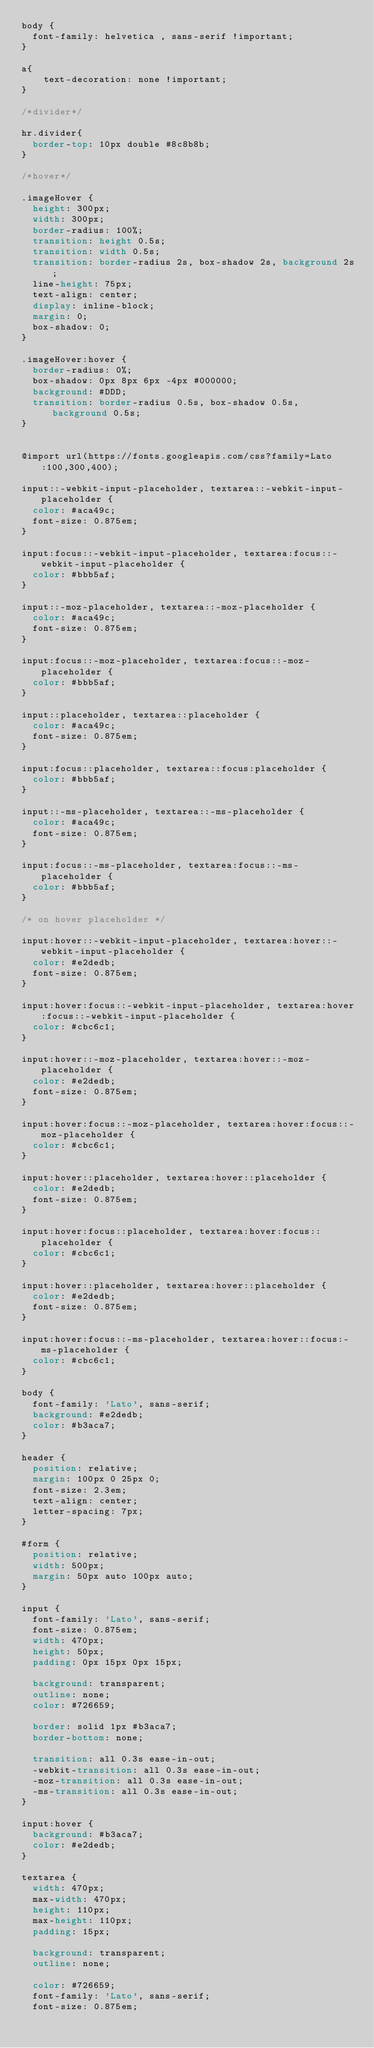Convert code to text. <code><loc_0><loc_0><loc_500><loc_500><_CSS_>body {
  font-family: helvetica , sans-serif !important;
}

a{
    text-decoration: none !important;
}

/*divider*/

hr.divider{
	border-top: 10px double #8c8b8b;
}

/*hover*/

.imageHover {
  height: 300px;
  width: 300px;
  border-radius: 100%;
  transition: height 0.5s;
  transition: width 0.5s;
  transition: border-radius 2s, box-shadow 2s, background 2s;
  line-height: 75px;
  text-align: center;
  display: inline-block;
  margin: 0;
  box-shadow: 0;
}

.imageHover:hover {
  border-radius: 0%;
  box-shadow: 0px 8px 6px -4px #000000;
  background: #DDD;
  transition: border-radius 0.5s, box-shadow 0.5s, background 0.5s;
}


@import url(https://fonts.googleapis.com/css?family=Lato:100,300,400);

input::-webkit-input-placeholder, textarea::-webkit-input-placeholder {
  color: #aca49c;
  font-size: 0.875em;
}

input:focus::-webkit-input-placeholder, textarea:focus::-webkit-input-placeholder {
  color: #bbb5af;
}

input::-moz-placeholder, textarea::-moz-placeholder {
  color: #aca49c;
  font-size: 0.875em;
}

input:focus::-moz-placeholder, textarea:focus::-moz-placeholder {
  color: #bbb5af;
}

input::placeholder, textarea::placeholder {
  color: #aca49c;
  font-size: 0.875em;
}

input:focus::placeholder, textarea::focus:placeholder {
  color: #bbb5af;
}

input::-ms-placeholder, textarea::-ms-placeholder {
  color: #aca49c;
  font-size: 0.875em;
}

input:focus::-ms-placeholder, textarea:focus::-ms-placeholder {
  color: #bbb5af;
}

/* on hover placeholder */

input:hover::-webkit-input-placeholder, textarea:hover::-webkit-input-placeholder {
  color: #e2dedb;
  font-size: 0.875em;
}

input:hover:focus::-webkit-input-placeholder, textarea:hover:focus::-webkit-input-placeholder {
  color: #cbc6c1;
}

input:hover::-moz-placeholder, textarea:hover::-moz-placeholder {
  color: #e2dedb;
  font-size: 0.875em;
}

input:hover:focus::-moz-placeholder, textarea:hover:focus::-moz-placeholder {
  color: #cbc6c1;
}

input:hover::placeholder, textarea:hover::placeholder {
  color: #e2dedb;
  font-size: 0.875em;
}

input:hover:focus::placeholder, textarea:hover:focus::placeholder {
  color: #cbc6c1;
}

input:hover::placeholder, textarea:hover::placeholder {
  color: #e2dedb;
  font-size: 0.875em;
}

input:hover:focus::-ms-placeholder, textarea:hover::focus:-ms-placeholder {
  color: #cbc6c1;
}

body {
  font-family: 'Lato', sans-serif;
  background: #e2dedb;
  color: #b3aca7;
}

header {
  position: relative;
  margin: 100px 0 25px 0;
  font-size: 2.3em;
  text-align: center;
  letter-spacing: 7px;
}

#form {
  position: relative;
  width: 500px;
  margin: 50px auto 100px auto;
}

input {
  font-family: 'Lato', sans-serif;
  font-size: 0.875em;
  width: 470px;
  height: 50px;
  padding: 0px 15px 0px 15px;
  
  background: transparent;
  outline: none;
  color: #726659;
  
  border: solid 1px #b3aca7;
  border-bottom: none;
  
  transition: all 0.3s ease-in-out;
  -webkit-transition: all 0.3s ease-in-out;
  -moz-transition: all 0.3s ease-in-out;
  -ms-transition: all 0.3s ease-in-out;
}

input:hover {
  background: #b3aca7;
  color: #e2dedb;
}

textarea {
  width: 470px;
  max-width: 470px;
  height: 110px;
  max-height: 110px;
  padding: 15px;
  
  background: transparent;
  outline: none;
  
  color: #726659;
  font-family: 'Lato', sans-serif;
  font-size: 0.875em;
  </code> 